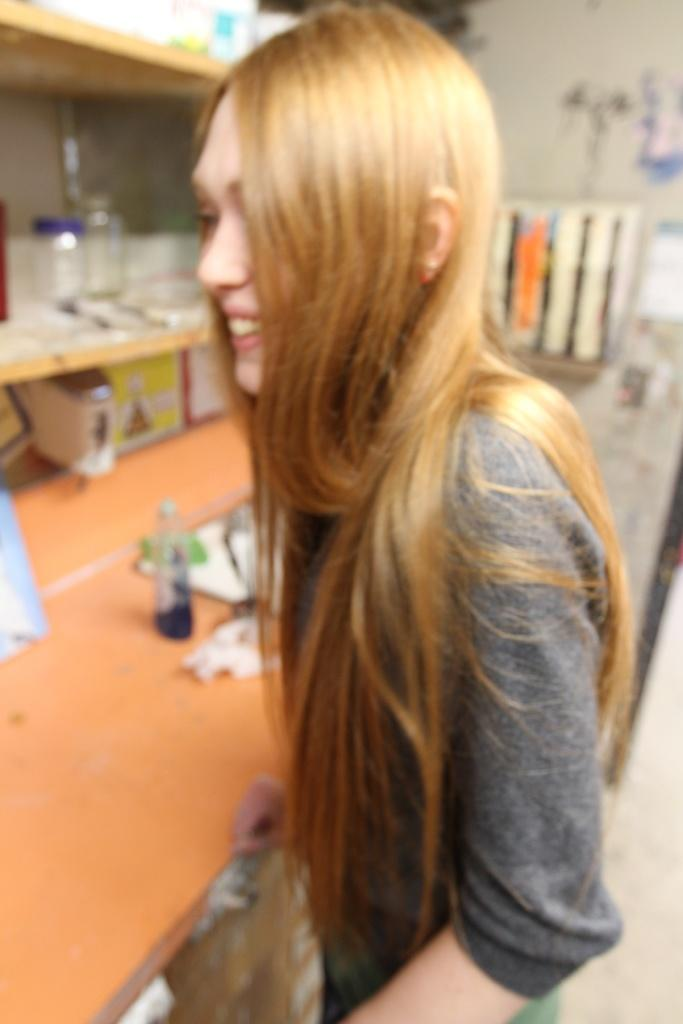Who is present in the image? There is a woman in the image. What is the woman doing in the image? The woman is standing and laughing. What object is in front of the woman? There is a table in front of the woman. What can be seen on the table? There is a bottle on the table. What structure is visible in the image? There is a rack in the image. What is on the rack? There are jars on the rack. How many trees are visible in the image? There are no trees visible in the image. What type of army is present in the image? There is no army present in the image. 